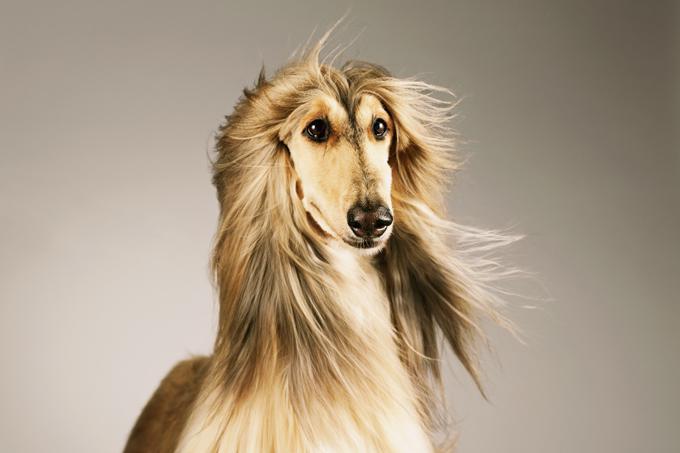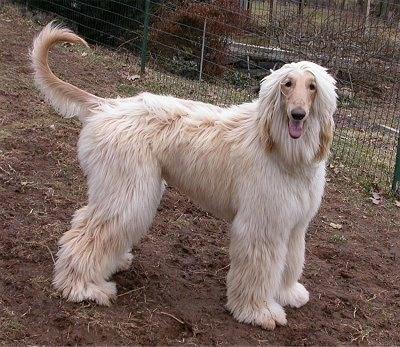The first image is the image on the left, the second image is the image on the right. Considering the images on both sides, is "One the dogs head is visible in the image on the left." valid? Answer yes or no. Yes. The first image is the image on the left, the second image is the image on the right. Assess this claim about the two images: "There is a dog's face in the left image with greenery behind it.". Correct or not? Answer yes or no. No. The first image is the image on the left, the second image is the image on the right. Analyze the images presented: Is the assertion "The hound on the left is more golden brown, and the one on the right is more cream colored." valid? Answer yes or no. Yes. 